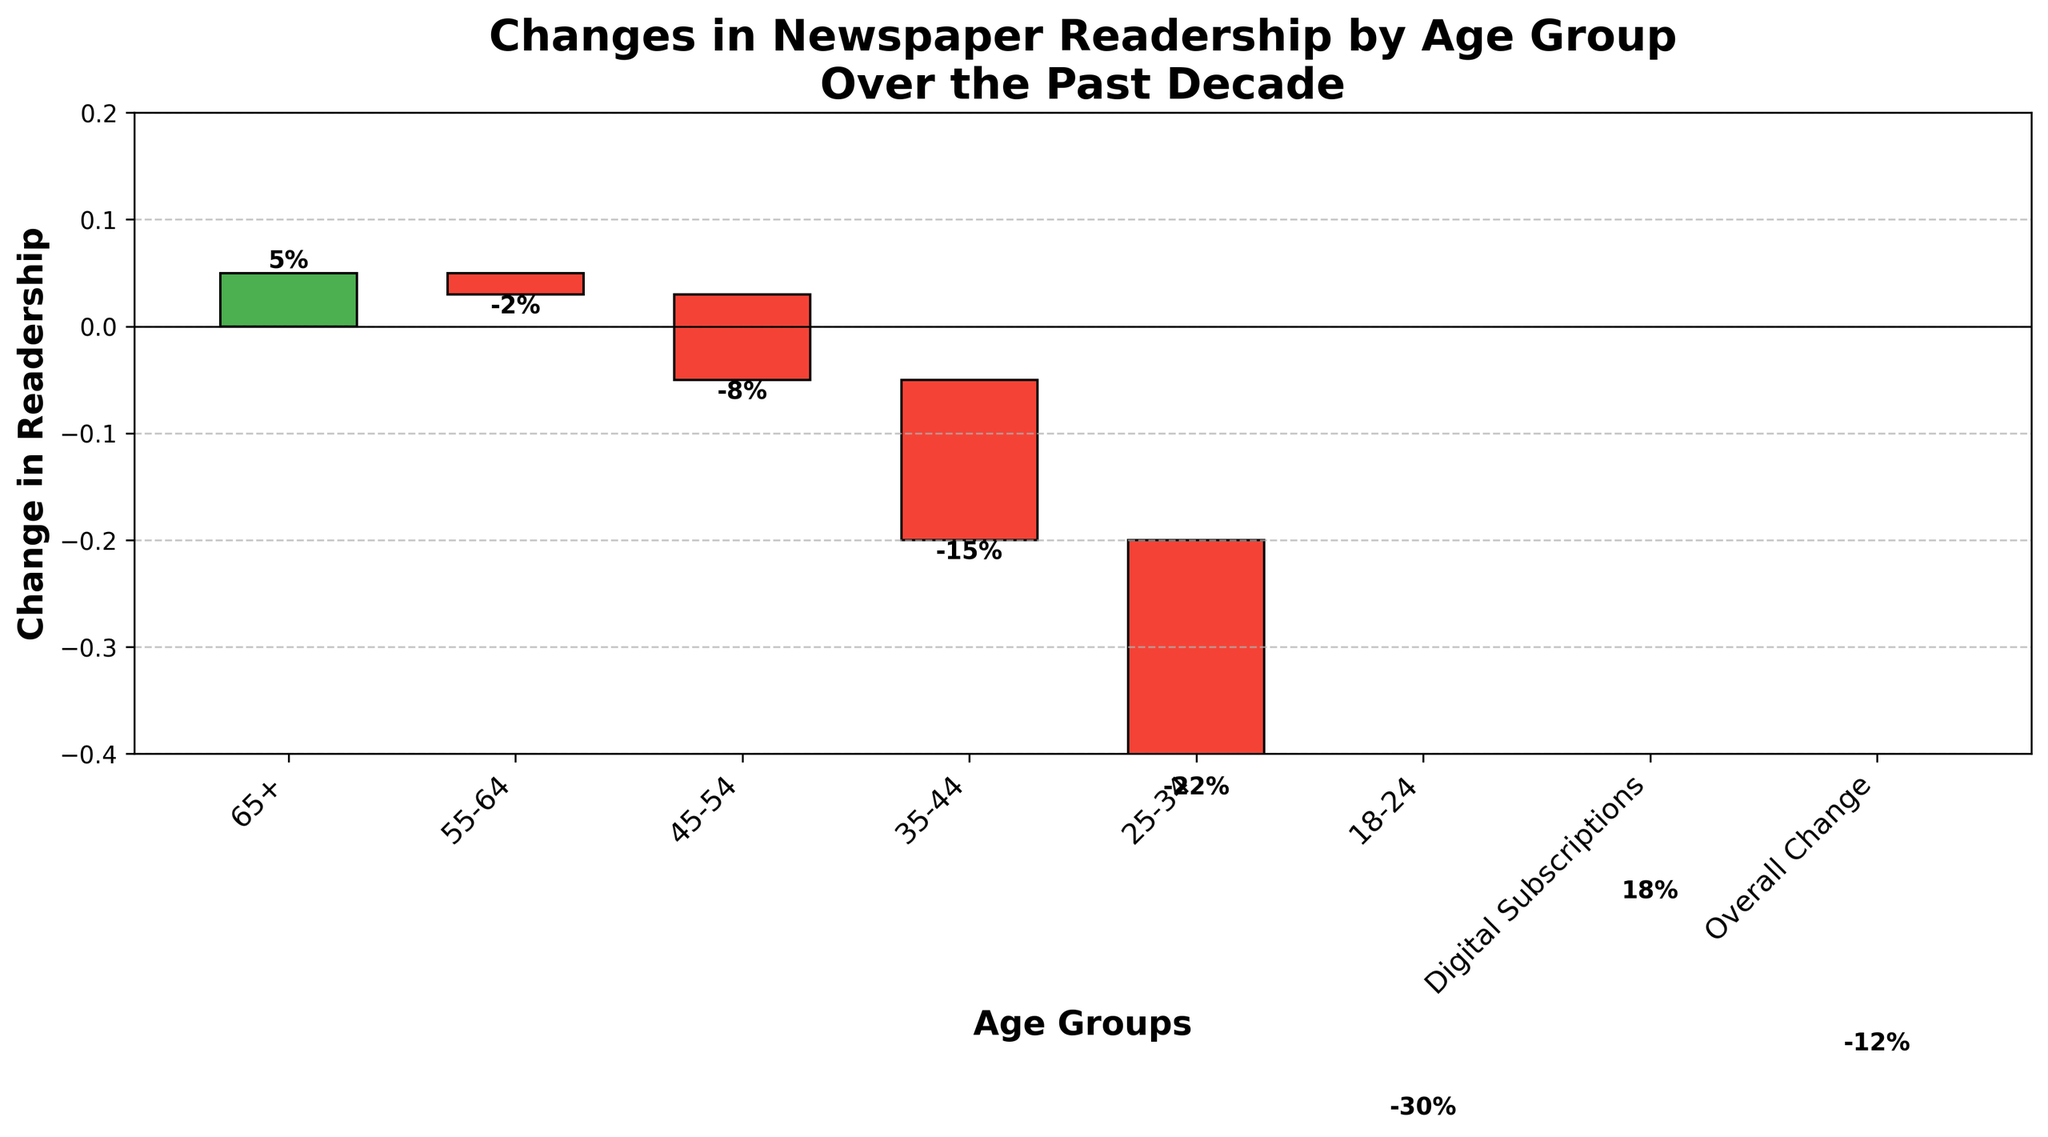What is the title of the chart? The title of the chart is found at the top and provides a summary of the chart's contents.
Answer: Changes in Newspaper Readership by Age Group Over the Past Decade How many age groups are represented in the chart? You can identify the different age groups by counting the distinct labels on the x-axis for age groups.
Answer: 6 Which age group saw the largest decrease in readership? Check the bars on the chart and identify the one with the lowest value, indicated by the highest negative percentage.
Answer: 18-24 By how much did the overall newspaper readership change over the past decade? Look for the "Overall Change" category and read the value associated with it.
Answer: -12% What is the average change in readership for all age groups (excluding digital subscriptions and overall change)? To calculate the average, add each percentage change for all age groups and then divide by the number of age groups (6). (-2% + (-8%) + (-15%) + (-22%) + (-30%) + 5%) / 6 = -72% / 6
Answer: -12% Which category had a positive change in readership aside from digital subscriptions? Identify the bar(s) with a positive value; only the 65+ age group and digital subscriptions have positive changes.
Answer: 65+ What is the difference in readership change between the 45-54 age group and the 25-34 age group? Determine the percentage change for each age group and calculate the difference. (-8%) - (-22%) = 14%
Answer: 14% Which age group is closest to the overall change in readership? Compare each age group's change value to the overall change (-12%), and identify the closest one. The 25-34 group has a change of -22%, making it closest.
Answer: 25-34 By how much did digital subscriptions increase compared to the overall change in readership? Compare the positive change for digital subscriptions with the overall change. Digital subscriptions increased by 18%, while overall change is -12%. So, 18% - (-12%) = 30%.
Answer: 30% Which age group's readership change brought down the overall change the most? Identify the age group with the most significant negative impact by finding the lowest value. The 18-24 group decreased by -30%.
Answer: 18-24 